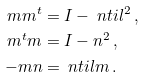Convert formula to latex. <formula><loc_0><loc_0><loc_500><loc_500>m m ^ { t } & = I - \ n t i l ^ { 2 } \, , \\ m ^ { t } m & = I - n ^ { 2 } \, , \\ - m n & = \ n t i l m \, .</formula> 